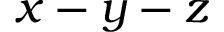<formula> <loc_0><loc_0><loc_500><loc_500>x - y - z</formula> 